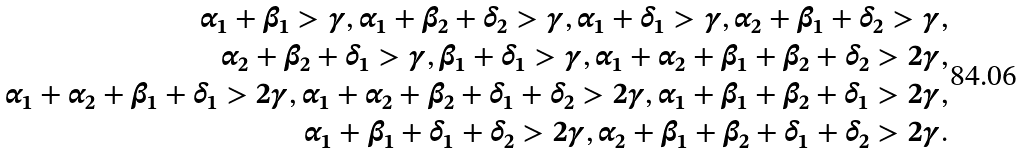Convert formula to latex. <formula><loc_0><loc_0><loc_500><loc_500>\alpha _ { 1 } + \beta _ { 1 } > \gamma , \alpha _ { 1 } + \beta _ { 2 } + \delta _ { 2 } > \gamma , \alpha _ { 1 } + \delta _ { 1 } > \gamma , \alpha _ { 2 } + \beta _ { 1 } + \delta _ { 2 } > \gamma , \\ \alpha _ { 2 } + \beta _ { 2 } + \delta _ { 1 } > \gamma , \beta _ { 1 } + \delta _ { 1 } > \gamma , \alpha _ { 1 } + \alpha _ { 2 } + \beta _ { 1 } + \beta _ { 2 } + \delta _ { 2 } > 2 \gamma , \\ \alpha _ { 1 } + \alpha _ { 2 } + \beta _ { 1 } + \delta _ { 1 } > 2 \gamma , \alpha _ { 1 } + \alpha _ { 2 } + \beta _ { 2 } + \delta _ { 1 } + \delta _ { 2 } > 2 \gamma , \alpha _ { 1 } + \beta _ { 1 } + \beta _ { 2 } + \delta _ { 1 } > 2 \gamma , \\ \alpha _ { 1 } + \beta _ { 1 } + \delta _ { 1 } + \delta _ { 2 } > 2 \gamma , \alpha _ { 2 } + \beta _ { 1 } + \beta _ { 2 } + \delta _ { 1 } + \delta _ { 2 } > 2 \gamma .</formula> 